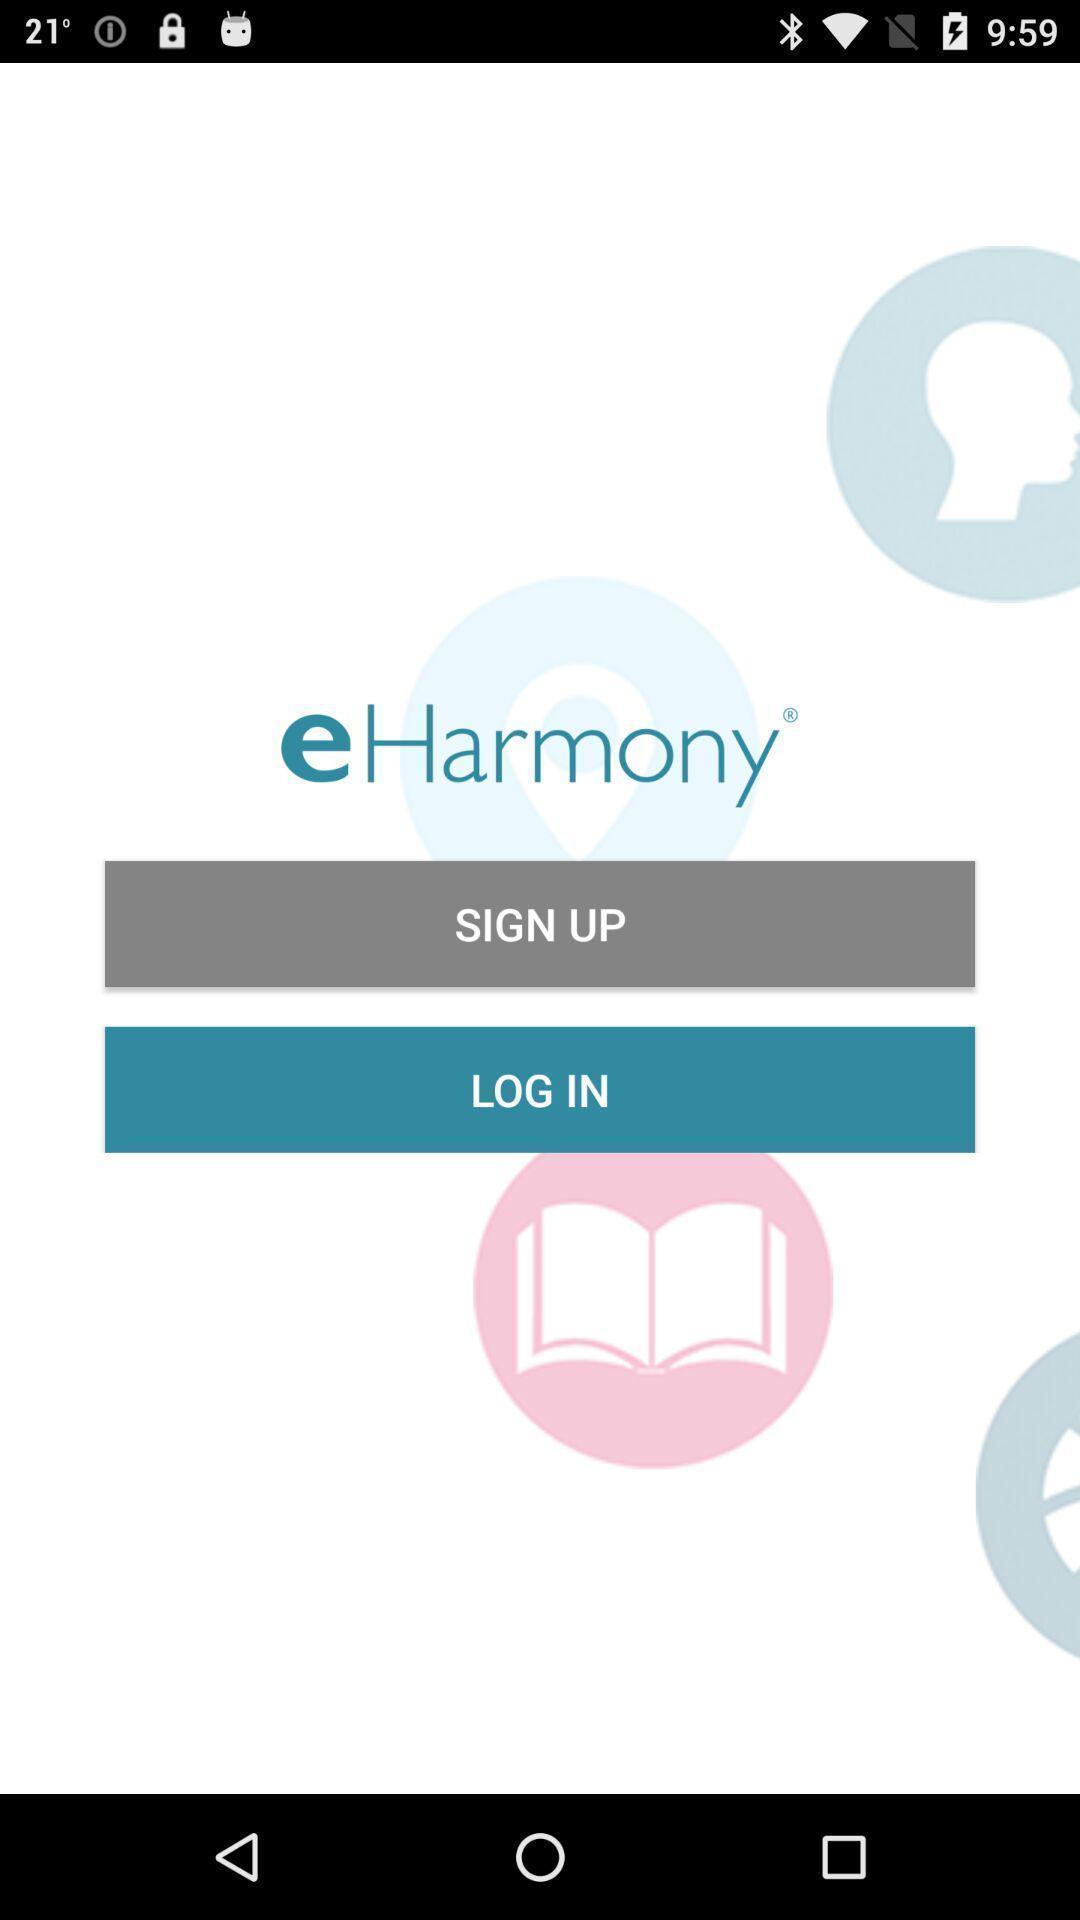Summarize the information in this screenshot. Welcome page of a kundli app. 